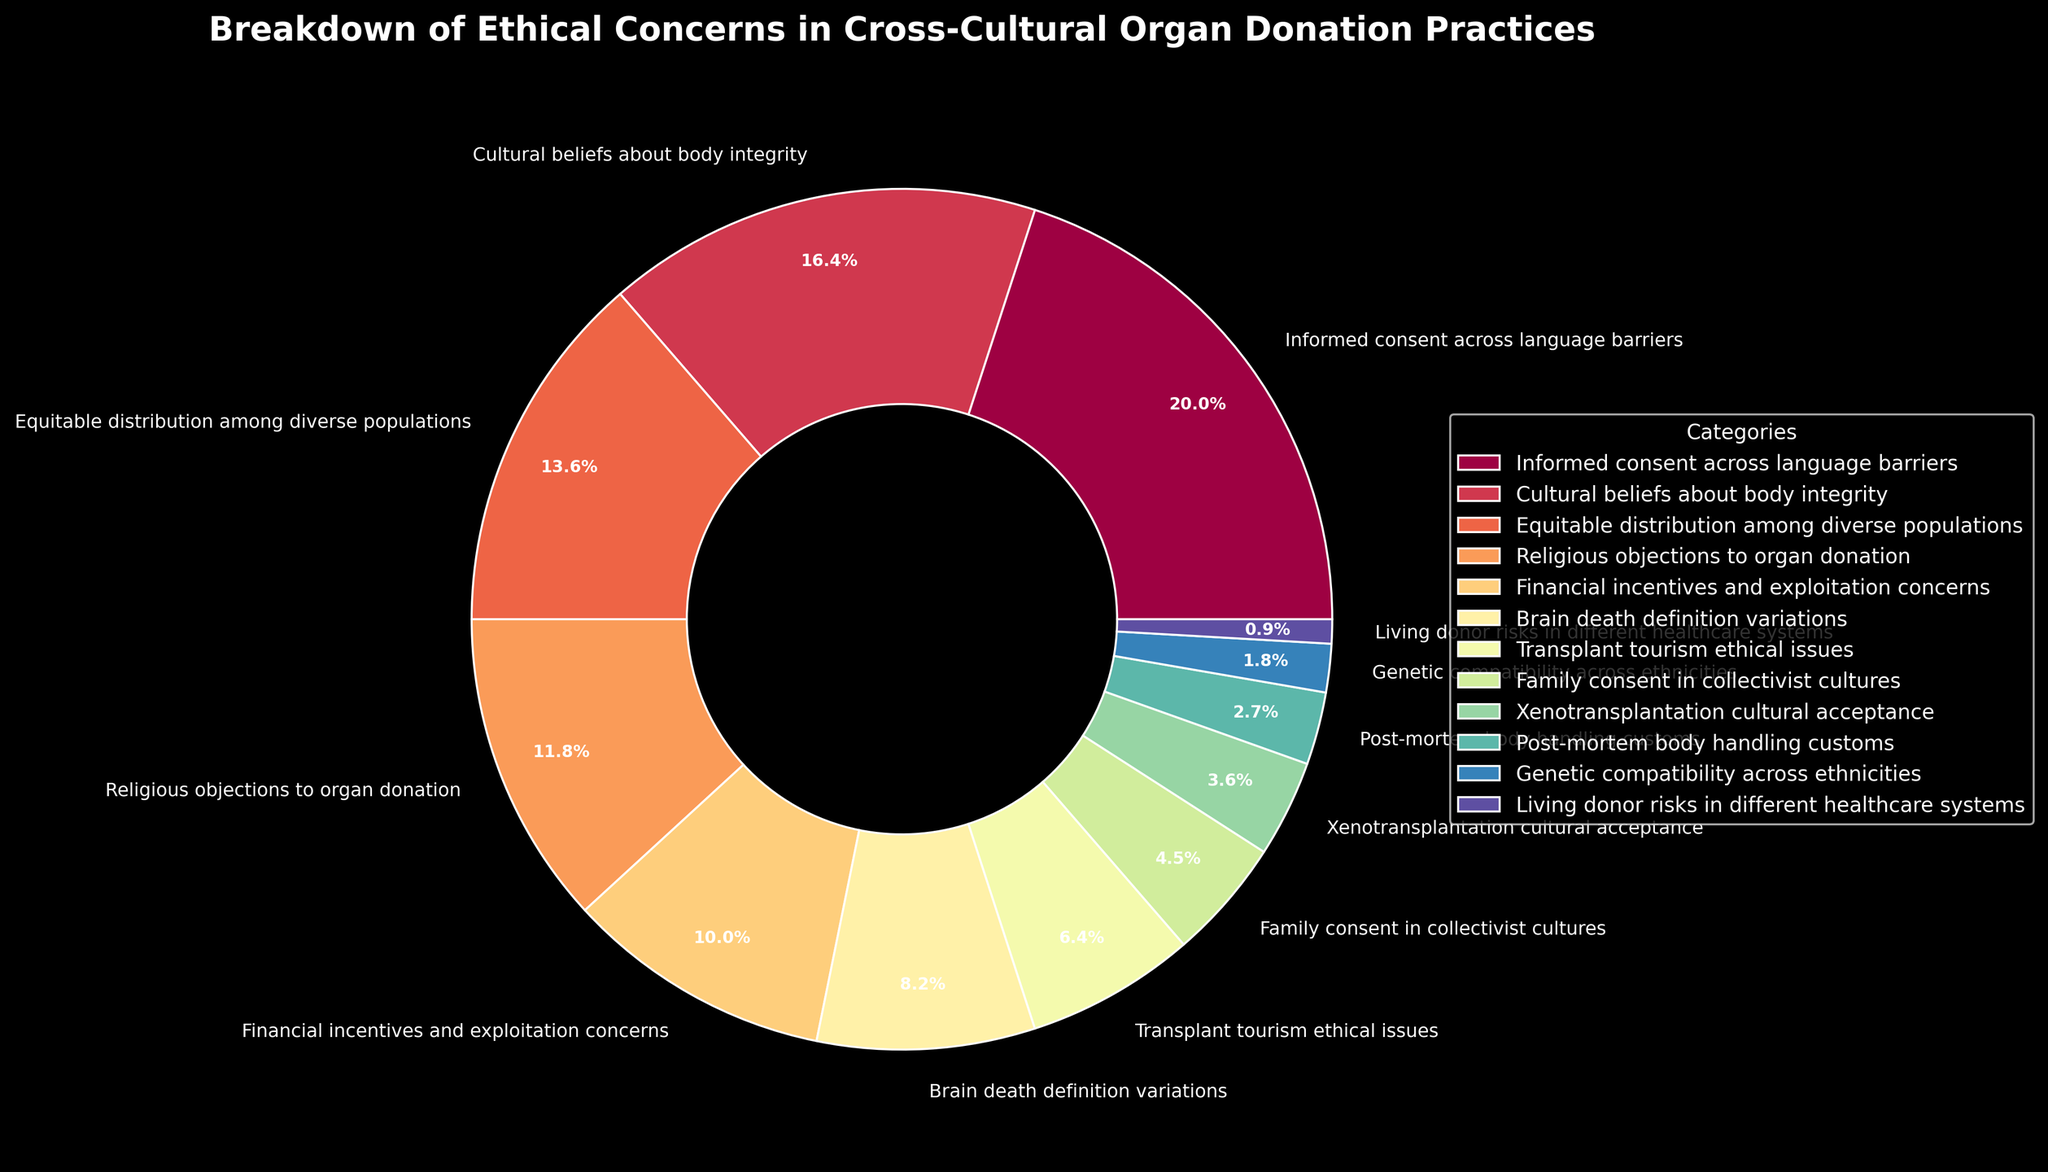what category has the highest percentage? The figure shows a pie chart with different categories of ethical concerns in cross-cultural organ donation practices. The slice with the highest percentage is labeled "Informed consent across language barriers" and shows 22%.
Answer: Informed consent across language barriers Which two categories together make up 31%? To find two categories that together make up 31%, we need to look for percentage values that sum to 31. Here "Informed consent across language barriers" (22%) and "Brain death definition variations" (9%) add up to 31%.
Answer: Informed consent across language barriers and Brain death definition variations Which category is higher in percentage: Cultural beliefs about body integrity or Equitable distribution among diverse populations? The pie chart indicates that "Cultural beliefs about body integrity" is 18%, while "Equitable distribution among diverse populations" is 15%.
Answer: Cultural beliefs about body integrity What is the total percentage of categories related to religious and cultural beliefs? Adding the percentages for categories related to religious and cultural beliefs (Cultural beliefs about body integrity 18% + Religious objections to organ donation 13%) gives us 31%.
Answer: 31% What percentage is represented by categories with less than 5% each? All categories with less than 5% are "Family consent in collectivist cultures" (5%) + "Xenotransplantation cultural acceptance" (4%) + "Post-mortem body handling customs" (3%) + "Genetic compatibility across ethnicities" (2%) + "Living donor risks in different healthcare systems" (1%), which sum to 15%.
Answer: 15% Which categories fall under financial concerns and what is their combined percentage? The category "Financial incentives and exploitation concerns" (11%) falls under financial concerns.
Answer: 11% How does the percentage of Brain death definition variations compare with Transplant tourism ethical issues? "Brain death definition variations" has a percentage of 9%, whereas "Transplant tourism ethical issues" has a lower percentage of 7%.
Answer: Brain death definition variations is higher What is the percentage difference between the highest and lowest categories? The highest category is "Informed consent across language barriers" with 22% and the lowest is "Living donor risks in different healthcare systems" with 1%. The difference is 22% - 1% = 21%.
Answer: 21% Which category related to permission/consent shows less than 10%? "Family consent in collectivist cultures" related to permission/consent shows 5% which is less than 10%.
Answer: Family consent in collectivist cultures How many categories have a percentage of 10% or more? The pie chart lists the categories with corresponding percentages greater than or equal to 10%. There are a total of 5 categories: "Informed consent across language barriers" (22%), "Cultural beliefs about body integrity" (18%), "Equitable distribution among diverse populations" (15%), "Religious objections to organ donation" (13%), and "Financial incentives and exploitation concerns" (11%).
Answer: 5 